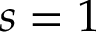Convert formula to latex. <formula><loc_0><loc_0><loc_500><loc_500>s = 1</formula> 